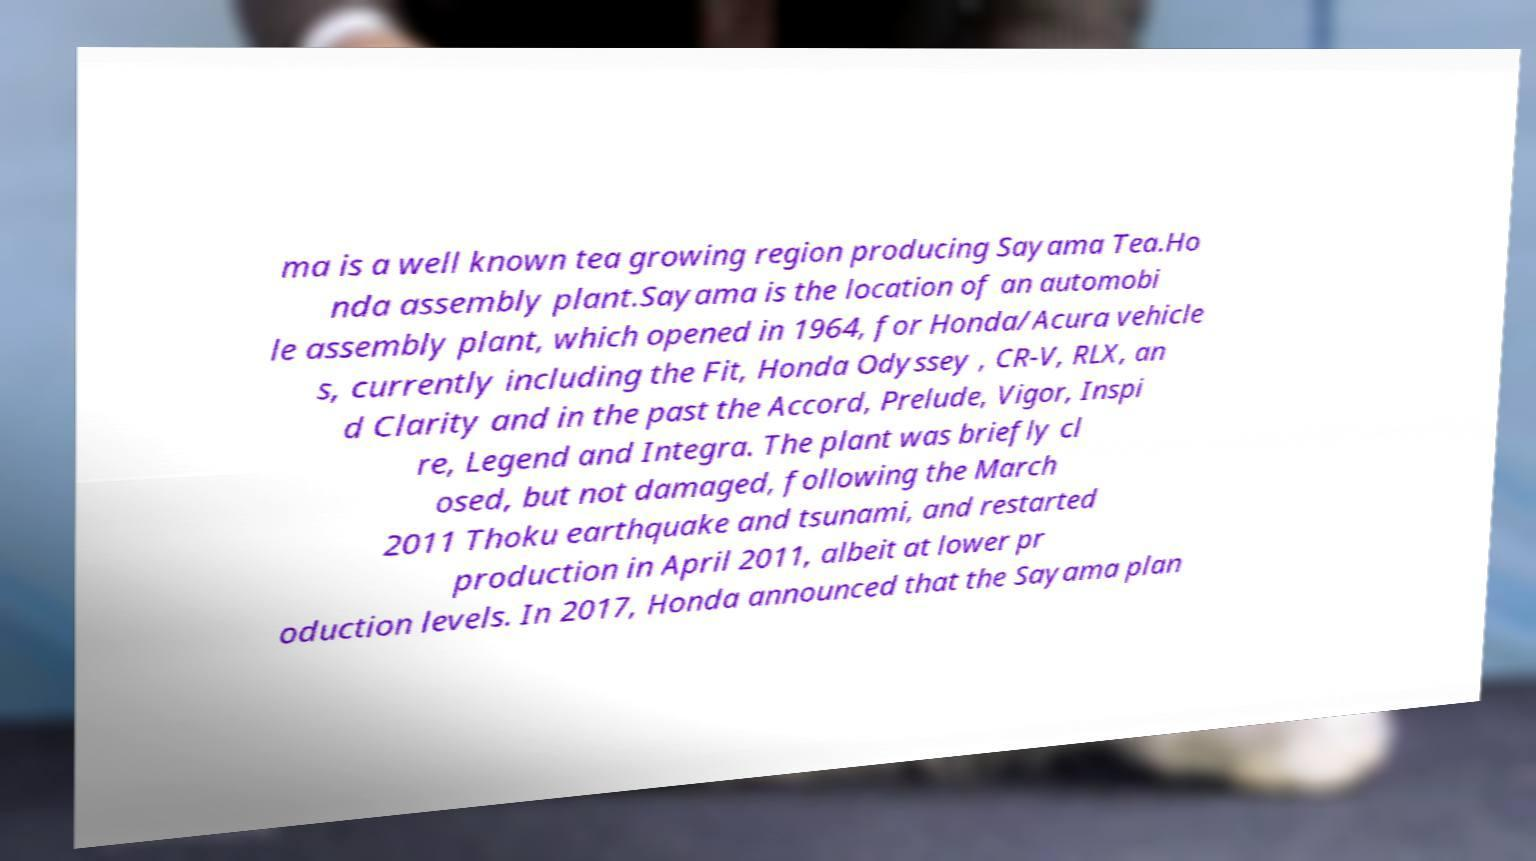What messages or text are displayed in this image? I need them in a readable, typed format. ma is a well known tea growing region producing Sayama Tea.Ho nda assembly plant.Sayama is the location of an automobi le assembly plant, which opened in 1964, for Honda/Acura vehicle s, currently including the Fit, Honda Odyssey , CR-V, RLX, an d Clarity and in the past the Accord, Prelude, Vigor, Inspi re, Legend and Integra. The plant was briefly cl osed, but not damaged, following the March 2011 Thoku earthquake and tsunami, and restarted production in April 2011, albeit at lower pr oduction levels. In 2017, Honda announced that the Sayama plan 